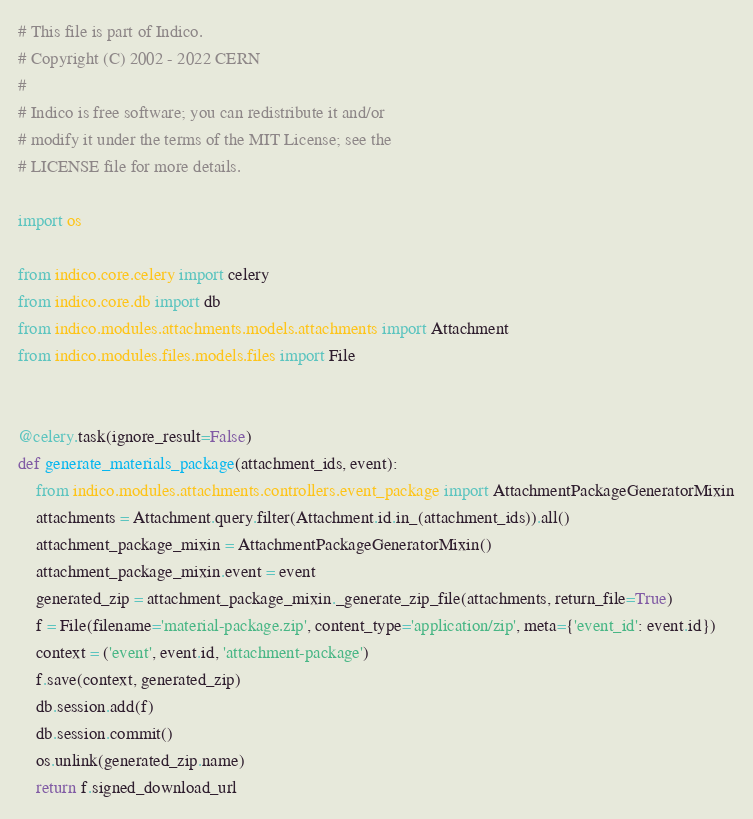Convert code to text. <code><loc_0><loc_0><loc_500><loc_500><_Python_># This file is part of Indico.
# Copyright (C) 2002 - 2022 CERN
#
# Indico is free software; you can redistribute it and/or
# modify it under the terms of the MIT License; see the
# LICENSE file for more details.

import os

from indico.core.celery import celery
from indico.core.db import db
from indico.modules.attachments.models.attachments import Attachment
from indico.modules.files.models.files import File


@celery.task(ignore_result=False)
def generate_materials_package(attachment_ids, event):
    from indico.modules.attachments.controllers.event_package import AttachmentPackageGeneratorMixin
    attachments = Attachment.query.filter(Attachment.id.in_(attachment_ids)).all()
    attachment_package_mixin = AttachmentPackageGeneratorMixin()
    attachment_package_mixin.event = event
    generated_zip = attachment_package_mixin._generate_zip_file(attachments, return_file=True)
    f = File(filename='material-package.zip', content_type='application/zip', meta={'event_id': event.id})
    context = ('event', event.id, 'attachment-package')
    f.save(context, generated_zip)
    db.session.add(f)
    db.session.commit()
    os.unlink(generated_zip.name)
    return f.signed_download_url
</code> 